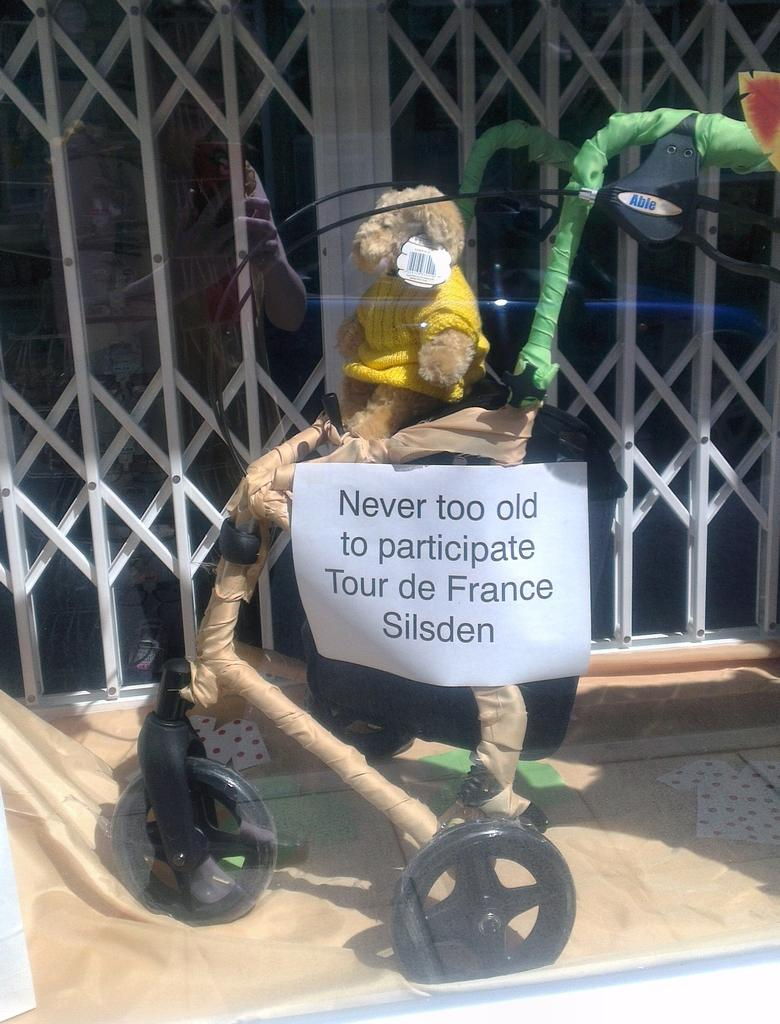What is the main subject of the image? There is a doll in the image. How is the doll being transported or displayed? The doll is in a cart with wheels. What type of structure can be seen in the background of the image? There is a gate visible in the image. What is the color of the gate? The gate is white in color. What type of instrument is the doll playing in the image? There is no instrument present in the image, and the doll is not shown playing any instrument. 